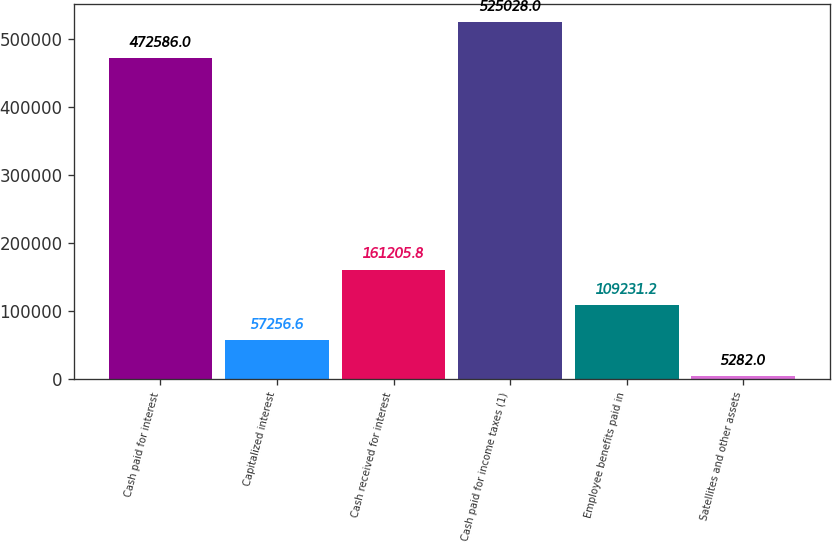Convert chart to OTSL. <chart><loc_0><loc_0><loc_500><loc_500><bar_chart><fcel>Cash paid for interest<fcel>Capitalized interest<fcel>Cash received for interest<fcel>Cash paid for income taxes (1)<fcel>Employee benefits paid in<fcel>Satellites and other assets<nl><fcel>472586<fcel>57256.6<fcel>161206<fcel>525028<fcel>109231<fcel>5282<nl></chart> 